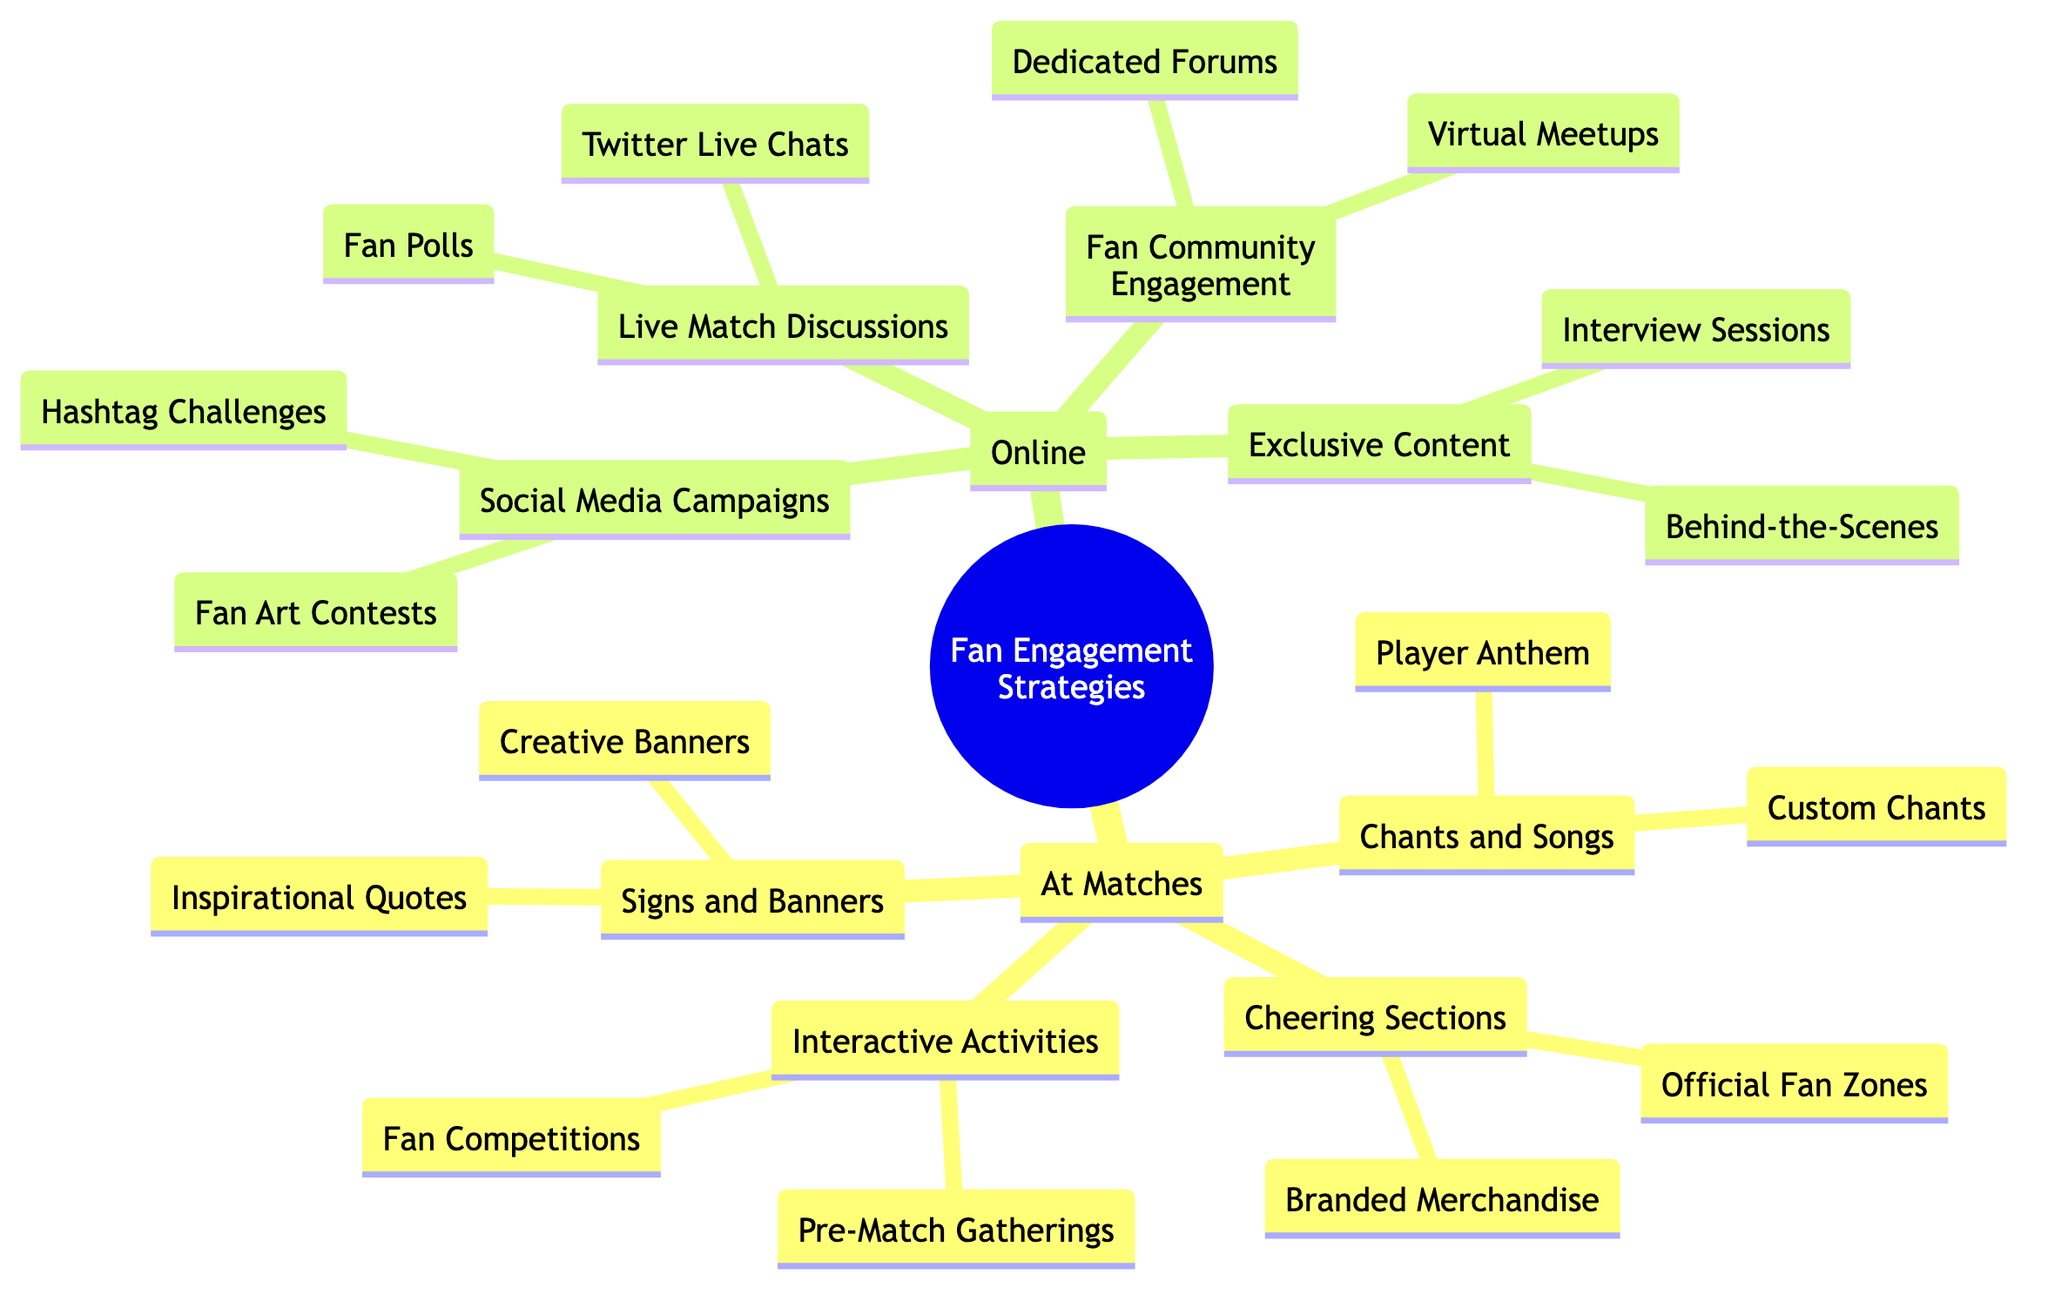What are the two main categories of fan engagement strategies in the diagram? The diagram shows two main categories: "At Matches" and "Online." These are the top-level nodes from which all other strategies branch off.
Answer: At Matches, Online How many types of cheering sections are mentioned? The diagram lists two types of cheering sections: "Official Fan Zones" and "Branded Merchandise." These sub-nodes list specific strategies under the Cheering Sections category.
Answer: 2 What type of online engagement involves artwork created by fans? "Fan Art Contests" is the specified subset under "Social Media Campaigns" that encourages fans to create and share artwork of Daniil.
Answer: Fan Art Contests Which activity under "At Matches" promotes fan interaction before the event? "Pre-Match Gatherings" is the activity that facilitates interaction among fans before matches take place, as indicated in the "Interactive Activities" section.
Answer: Pre-Match Gatherings What are the two content types provided under "Exclusive Content"? The diagram specifies "Behind-the-Scenes" and "Interview Sessions" as the two types of exclusive content aimed to engage fans with more personal insights into Daniil’s life.
Answer: Behind-the-Scenes, Interview Sessions How does the "Live Match Discussions" section engage fans during games? This section includes activities such as "Twitter Live Chats" and "Fan Polls," allowing fans to interact and discuss in real-time during matches, which enhances their engagement.
Answer: Twitter Live Chats, Fan Polls What is the purpose of using hashtags in "Social Media Campaigns"? Hashtags like #GoDaniil and #MedvedevMagic help to organize and promote conversations or challenges that fans can participate in related to Daniil, allowing for cohesive fan engagement.
Answer: Organize conversations, promote participation Which node indicates competitions related to fans' attire or creativity? "Fan Competitions" found in the "Interactive Activities" branch indicates competitions that focus on fans' creativity, such as the best-dressed and best-banner contests.
Answer: Fan Competitions 